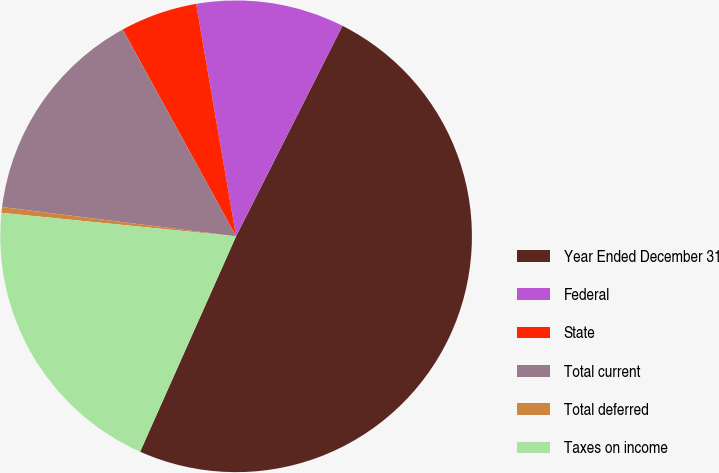Convert chart to OTSL. <chart><loc_0><loc_0><loc_500><loc_500><pie_chart><fcel>Year Ended December 31<fcel>Federal<fcel>State<fcel>Total current<fcel>Total deferred<fcel>Taxes on income<nl><fcel>49.22%<fcel>10.16%<fcel>5.27%<fcel>15.04%<fcel>0.39%<fcel>19.92%<nl></chart> 